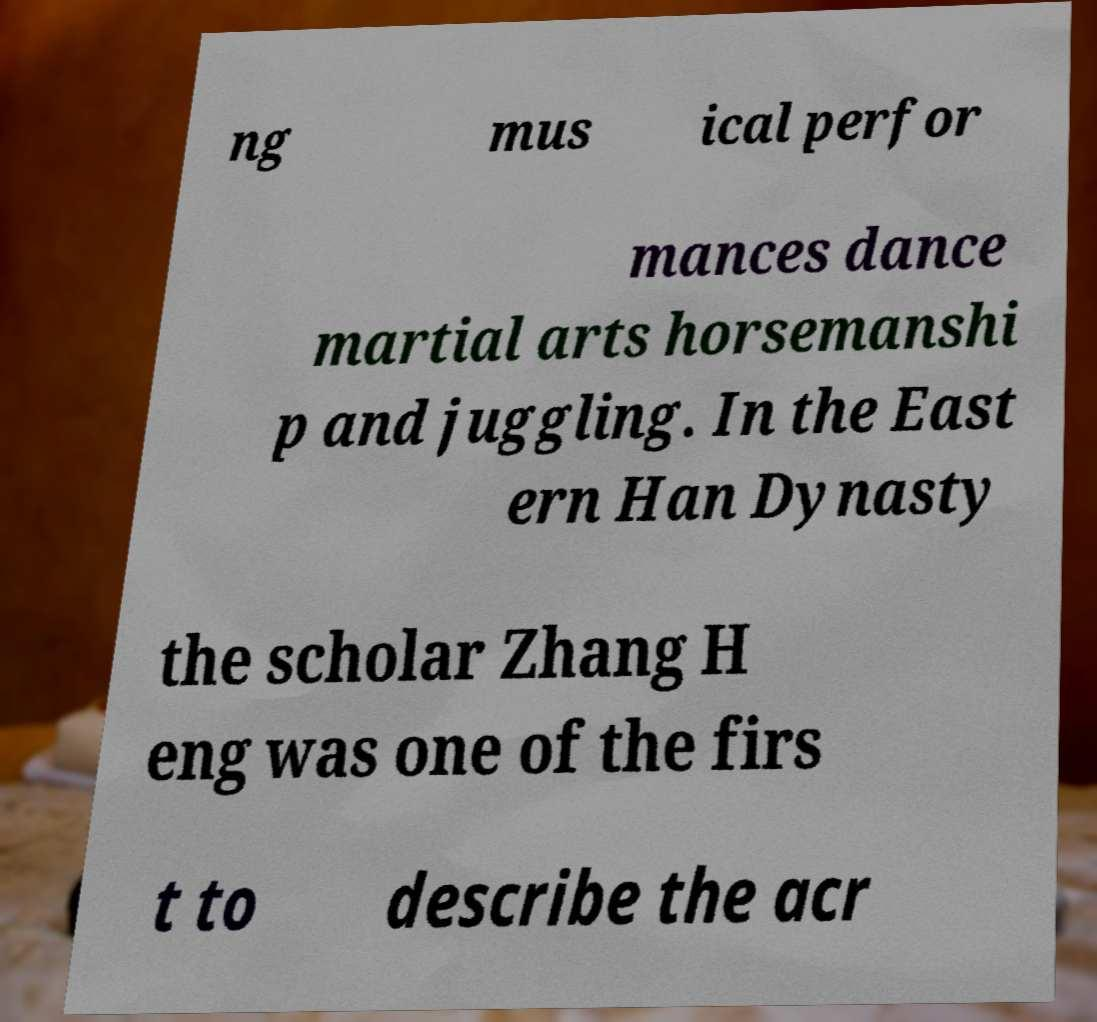Could you assist in decoding the text presented in this image and type it out clearly? ng mus ical perfor mances dance martial arts horsemanshi p and juggling. In the East ern Han Dynasty the scholar Zhang H eng was one of the firs t to describe the acr 